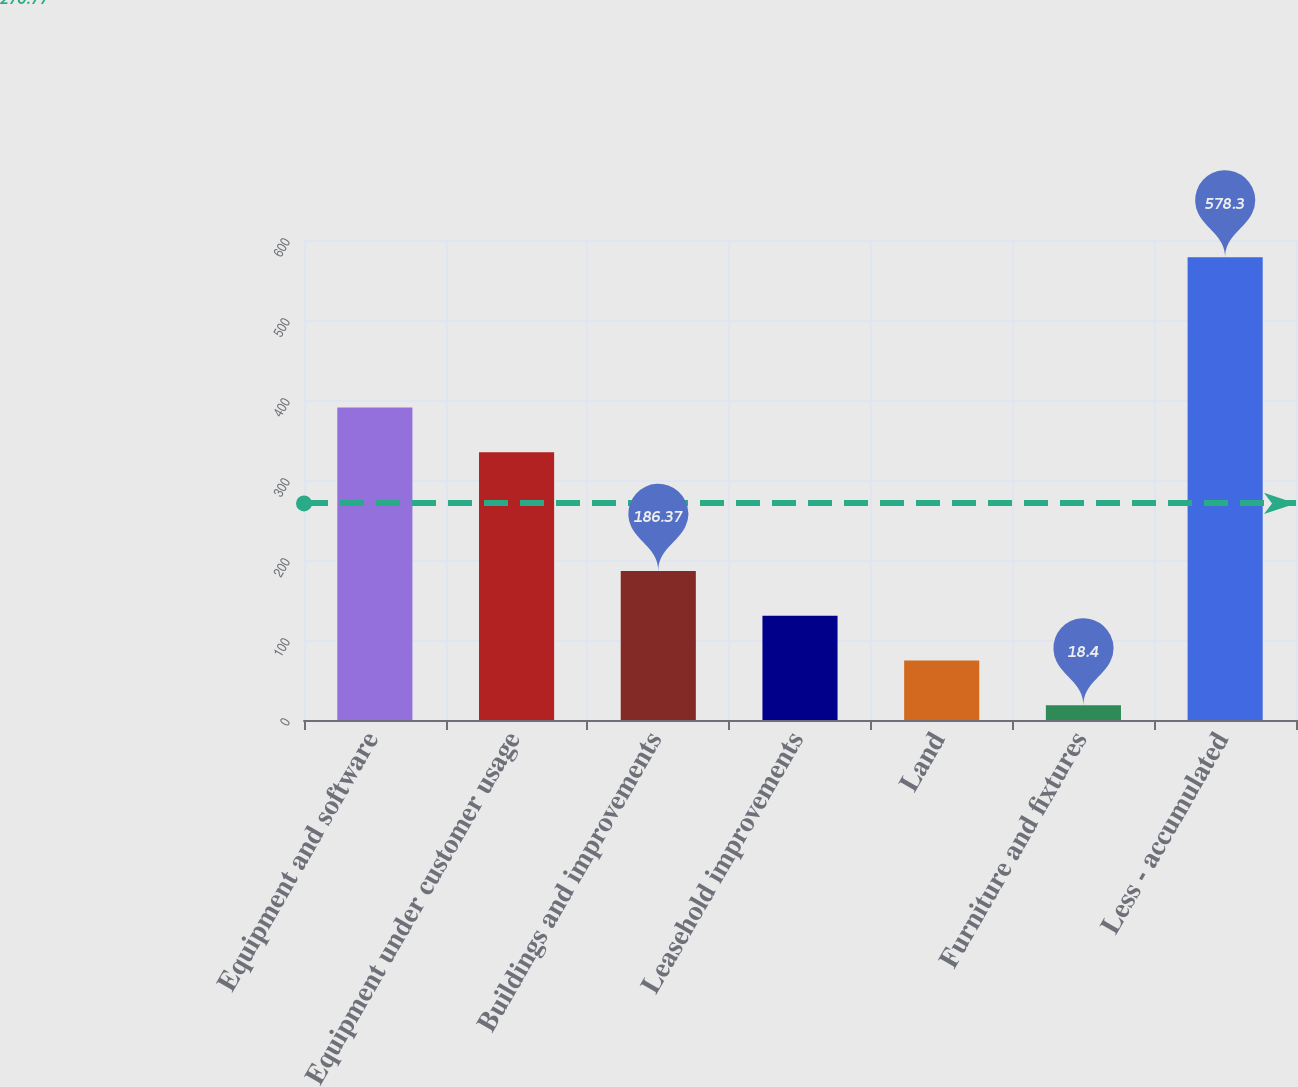<chart> <loc_0><loc_0><loc_500><loc_500><bar_chart><fcel>Equipment and software<fcel>Equipment under customer usage<fcel>Buildings and improvements<fcel>Leasehold improvements<fcel>Land<fcel>Furniture and fixtures<fcel>Less - accumulated<nl><fcel>390.59<fcel>334.6<fcel>186.37<fcel>130.38<fcel>74.39<fcel>18.4<fcel>578.3<nl></chart> 